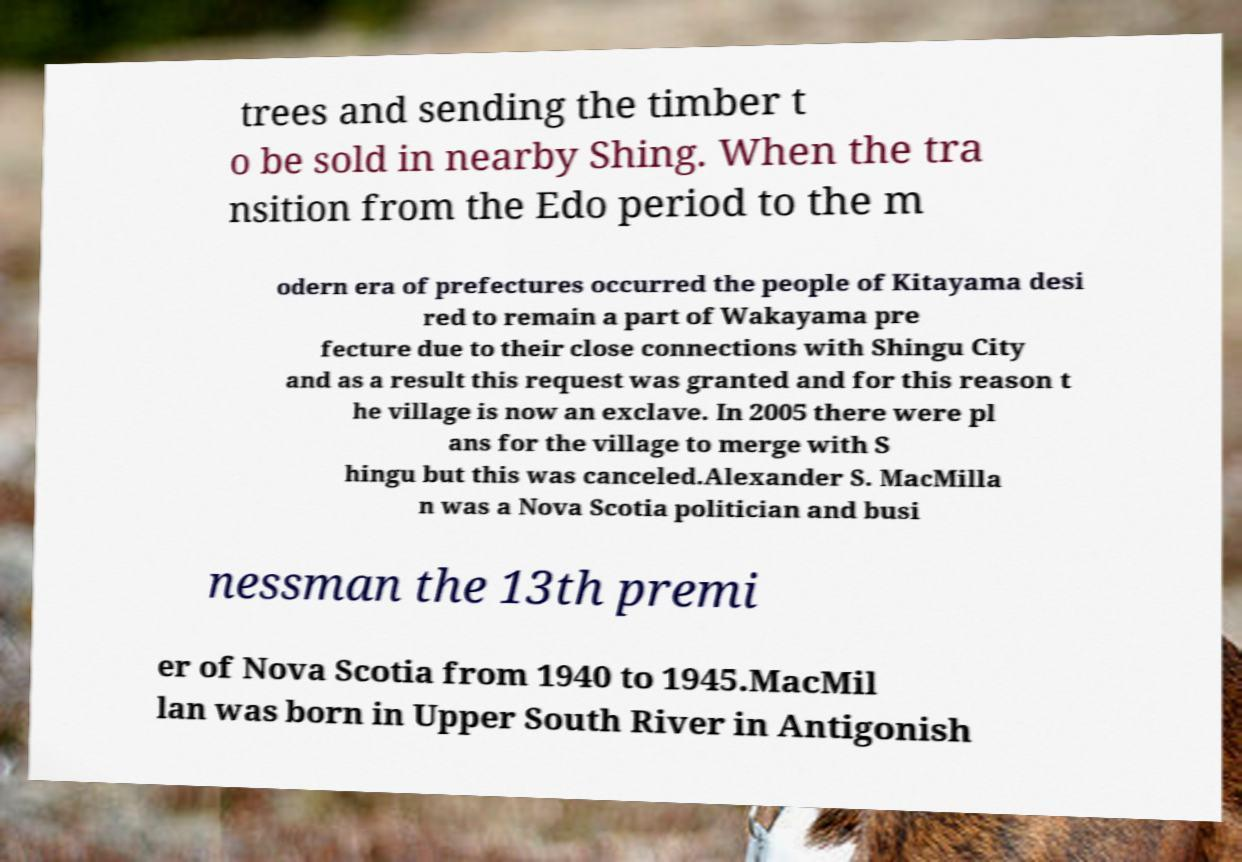Please identify and transcribe the text found in this image. trees and sending the timber t o be sold in nearby Shing. When the tra nsition from the Edo period to the m odern era of prefectures occurred the people of Kitayama desi red to remain a part of Wakayama pre fecture due to their close connections with Shingu City and as a result this request was granted and for this reason t he village is now an exclave. In 2005 there were pl ans for the village to merge with S hingu but this was canceled.Alexander S. MacMilla n was a Nova Scotia politician and busi nessman the 13th premi er of Nova Scotia from 1940 to 1945.MacMil lan was born in Upper South River in Antigonish 